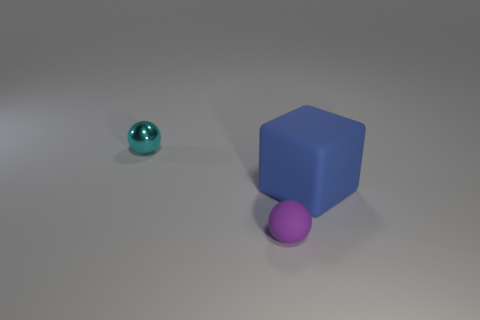Add 1 big rubber cubes. How many objects exist? 4 Subtract all cubes. How many objects are left? 2 Subtract 0 red cubes. How many objects are left? 3 Subtract all tiny matte spheres. Subtract all large gray blocks. How many objects are left? 2 Add 2 purple things. How many purple things are left? 3 Add 2 shiny objects. How many shiny objects exist? 3 